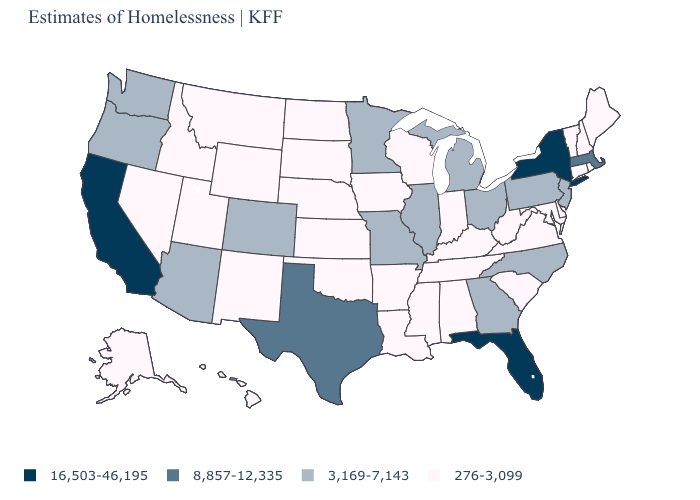What is the value of Washington?
Answer briefly. 3,169-7,143. What is the value of South Dakota?
Give a very brief answer. 276-3,099. What is the lowest value in the USA?
Answer briefly. 276-3,099. What is the value of New Jersey?
Give a very brief answer. 3,169-7,143. Is the legend a continuous bar?
Keep it brief. No. Name the states that have a value in the range 276-3,099?
Write a very short answer. Alabama, Alaska, Arkansas, Connecticut, Delaware, Hawaii, Idaho, Indiana, Iowa, Kansas, Kentucky, Louisiana, Maine, Maryland, Mississippi, Montana, Nebraska, Nevada, New Hampshire, New Mexico, North Dakota, Oklahoma, Rhode Island, South Carolina, South Dakota, Tennessee, Utah, Vermont, Virginia, West Virginia, Wisconsin, Wyoming. What is the highest value in states that border South Carolina?
Be succinct. 3,169-7,143. Which states hav the highest value in the Northeast?
Keep it brief. New York. Name the states that have a value in the range 16,503-46,195?
Keep it brief. California, Florida, New York. Among the states that border Nevada , which have the highest value?
Keep it brief. California. Does Washington have a higher value than Illinois?
Concise answer only. No. Which states have the lowest value in the USA?
Concise answer only. Alabama, Alaska, Arkansas, Connecticut, Delaware, Hawaii, Idaho, Indiana, Iowa, Kansas, Kentucky, Louisiana, Maine, Maryland, Mississippi, Montana, Nebraska, Nevada, New Hampshire, New Mexico, North Dakota, Oklahoma, Rhode Island, South Carolina, South Dakota, Tennessee, Utah, Vermont, Virginia, West Virginia, Wisconsin, Wyoming. Name the states that have a value in the range 3,169-7,143?
Be succinct. Arizona, Colorado, Georgia, Illinois, Michigan, Minnesota, Missouri, New Jersey, North Carolina, Ohio, Oregon, Pennsylvania, Washington. What is the highest value in the South ?
Concise answer only. 16,503-46,195. Does Montana have the lowest value in the USA?
Be succinct. Yes. 